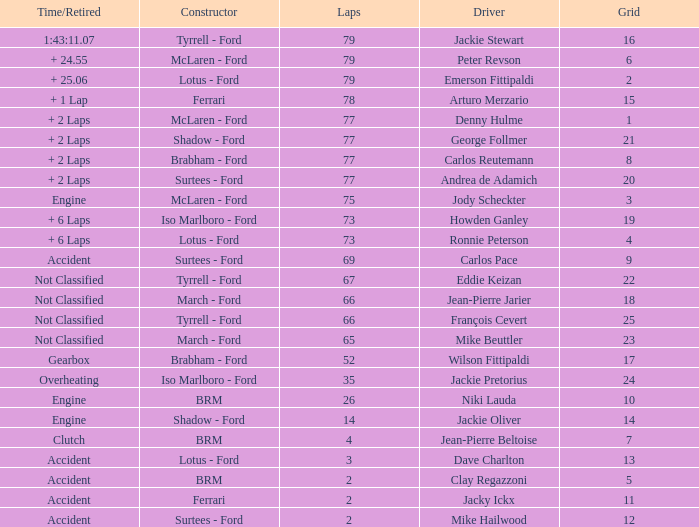Could you parse the entire table as a dict? {'header': ['Time/Retired', 'Constructor', 'Laps', 'Driver', 'Grid'], 'rows': [['1:43:11.07', 'Tyrrell - Ford', '79', 'Jackie Stewart', '16'], ['+ 24.55', 'McLaren - Ford', '79', 'Peter Revson', '6'], ['+ 25.06', 'Lotus - Ford', '79', 'Emerson Fittipaldi', '2'], ['+ 1 Lap', 'Ferrari', '78', 'Arturo Merzario', '15'], ['+ 2 Laps', 'McLaren - Ford', '77', 'Denny Hulme', '1'], ['+ 2 Laps', 'Shadow - Ford', '77', 'George Follmer', '21'], ['+ 2 Laps', 'Brabham - Ford', '77', 'Carlos Reutemann', '8'], ['+ 2 Laps', 'Surtees - Ford', '77', 'Andrea de Adamich', '20'], ['Engine', 'McLaren - Ford', '75', 'Jody Scheckter', '3'], ['+ 6 Laps', 'Iso Marlboro - Ford', '73', 'Howden Ganley', '19'], ['+ 6 Laps', 'Lotus - Ford', '73', 'Ronnie Peterson', '4'], ['Accident', 'Surtees - Ford', '69', 'Carlos Pace', '9'], ['Not Classified', 'Tyrrell - Ford', '67', 'Eddie Keizan', '22'], ['Not Classified', 'March - Ford', '66', 'Jean-Pierre Jarier', '18'], ['Not Classified', 'Tyrrell - Ford', '66', 'François Cevert', '25'], ['Not Classified', 'March - Ford', '65', 'Mike Beuttler', '23'], ['Gearbox', 'Brabham - Ford', '52', 'Wilson Fittipaldi', '17'], ['Overheating', 'Iso Marlboro - Ford', '35', 'Jackie Pretorius', '24'], ['Engine', 'BRM', '26', 'Niki Lauda', '10'], ['Engine', 'Shadow - Ford', '14', 'Jackie Oliver', '14'], ['Clutch', 'BRM', '4', 'Jean-Pierre Beltoise', '7'], ['Accident', 'Lotus - Ford', '3', 'Dave Charlton', '13'], ['Accident', 'BRM', '2', 'Clay Regazzoni', '5'], ['Accident', 'Ferrari', '2', 'Jacky Ickx', '11'], ['Accident', 'Surtees - Ford', '2', 'Mike Hailwood', '12']]} How much time is required for less than 35 laps and less than 10 grids? Clutch, Accident. 